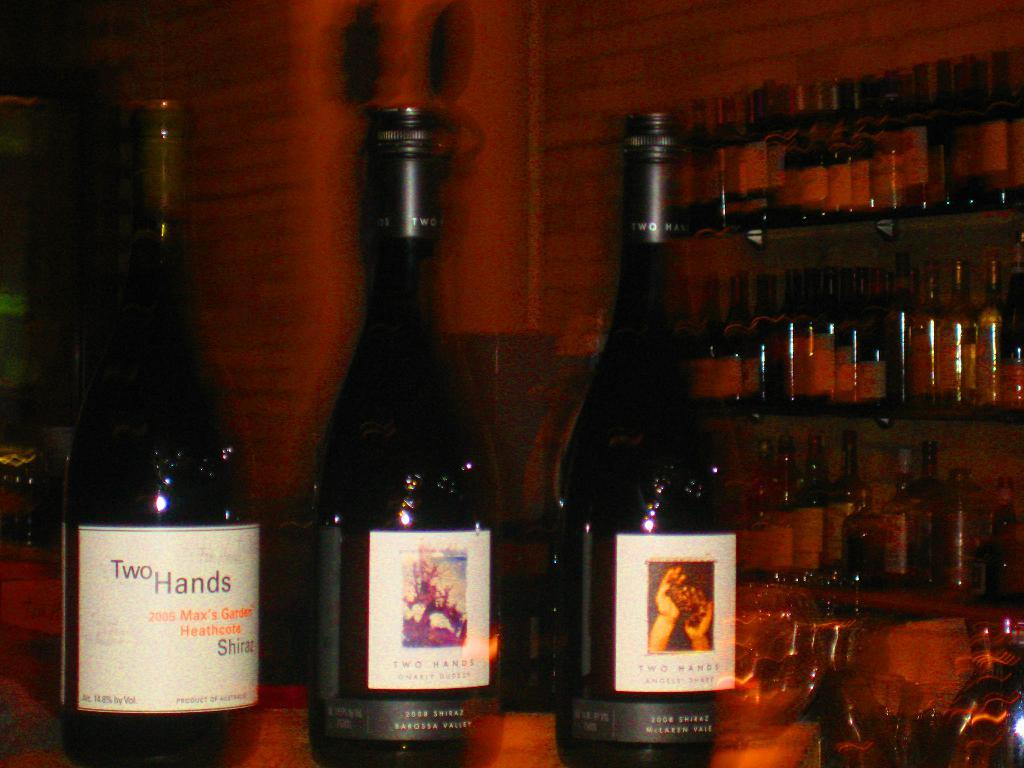<image>
Provide a brief description of the given image. three bottles of wine include Two Hands in the forefront of a bar 